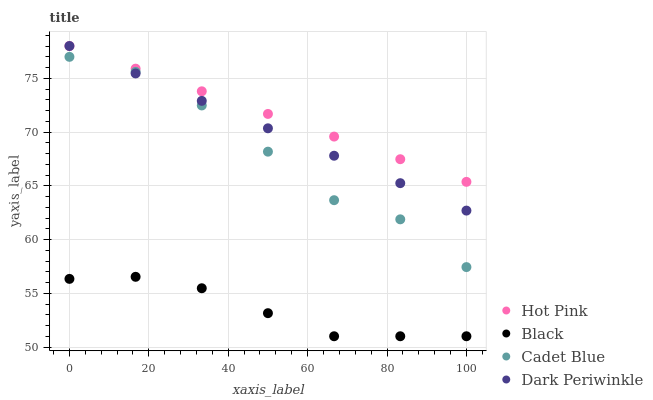Does Black have the minimum area under the curve?
Answer yes or no. Yes. Does Hot Pink have the maximum area under the curve?
Answer yes or no. Yes. Does Hot Pink have the minimum area under the curve?
Answer yes or no. No. Does Black have the maximum area under the curve?
Answer yes or no. No. Is Hot Pink the smoothest?
Answer yes or no. Yes. Is Cadet Blue the roughest?
Answer yes or no. Yes. Is Black the smoothest?
Answer yes or no. No. Is Black the roughest?
Answer yes or no. No. Does Black have the lowest value?
Answer yes or no. Yes. Does Hot Pink have the lowest value?
Answer yes or no. No. Does Dark Periwinkle have the highest value?
Answer yes or no. Yes. Does Black have the highest value?
Answer yes or no. No. Is Black less than Cadet Blue?
Answer yes or no. Yes. Is Hot Pink greater than Black?
Answer yes or no. Yes. Does Dark Periwinkle intersect Cadet Blue?
Answer yes or no. Yes. Is Dark Periwinkle less than Cadet Blue?
Answer yes or no. No. Is Dark Periwinkle greater than Cadet Blue?
Answer yes or no. No. Does Black intersect Cadet Blue?
Answer yes or no. No. 